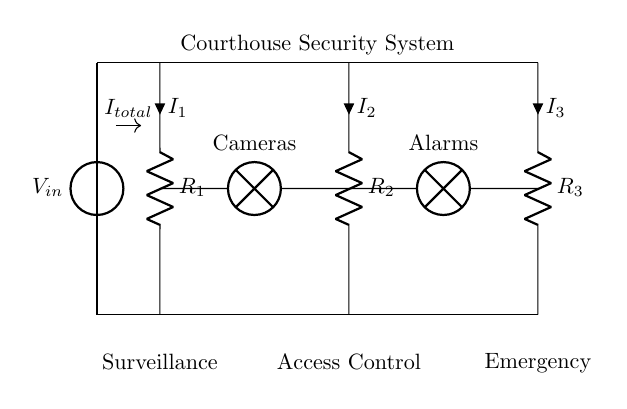What is the total current in the circuit? The total current, represented as I_total, is the sum of the currents flowing through each branch (I_1, I_2, I_3). It is the input current from the voltage source before it divides into the three branches.
Answer: I_total What components are connected to the first branch? The first branch consists of a resistor (R_1) and a lamp labeled as Cameras. The lamp is connected in series with the resistor, indicating that the current must pass through them sequentially.
Answer: R_1, Cameras Which branch has the highest resistance? To determine this, we compare the values of resistors R_1, R_2, and R_3. The branch with the highest resistance will determine the lower current according to the current divider rule. The specific resistances are not given, but R_3 is suggested to be higher based on subsequent positioning if assumed.
Answer: R_3 What is the voltage source value? The voltage source is represented as V_in, but its specific numerical value is not indicated in the diagram. It provides the supply voltage that drives the entire circuit.
Answer: V_in How is the current distributed among the branches? The current divider rule states that the current entering the parallel branches divides inversely proportional to the resistance of each branch. For example, if R_1 is low and R_3 is high, I_1 will be greater than I_3.
Answer: Inversely proportional to resistance 